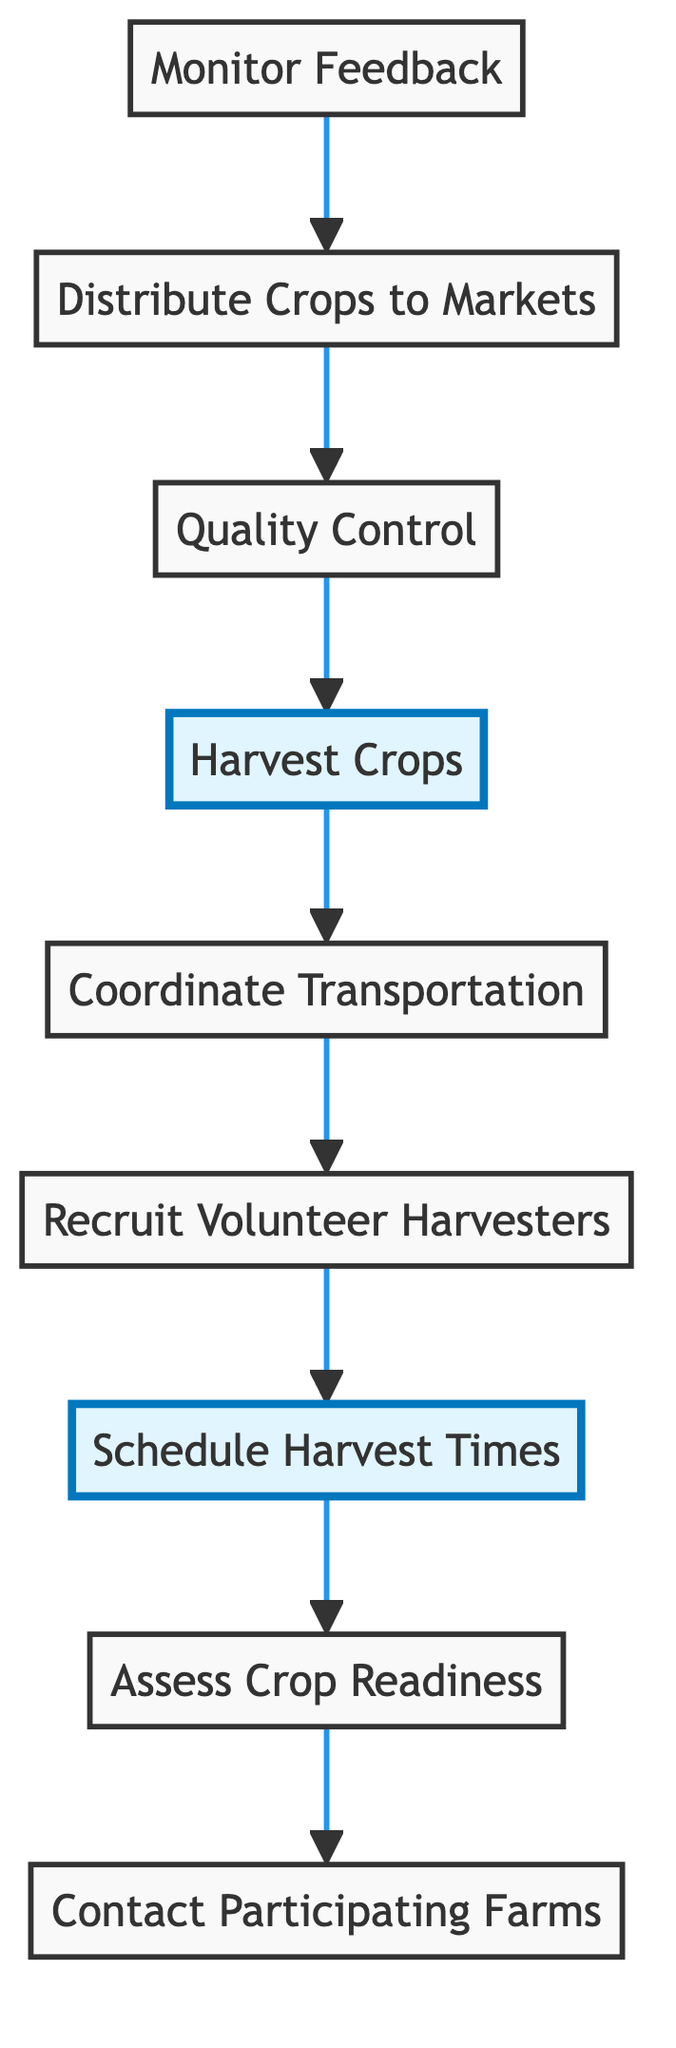What is the first step in the coordination process? The first step, shown at the bottom of the flowchart, is "Contact Participating Farms." This is where outreach begins to enlist the local farms for participation in the harvest coordination program.
Answer: Contact Participating Farms How many distinct steps are in the process? By counting the boxes, there are a total of 9 distinct steps present in the diagram, each representing a stage in the harvesting coordination process.
Answer: 9 What is the last step shown in the process? The last step, at the top of the flowchart, is "Monitor Feedback." This indicates the importance of reviewing feedback after distributing crops to improve future processes.
Answer: Monitor Feedback Which step comes immediately before "Quality Control"? "Distribute Crops to Markets" directly precedes "Quality Control," meaning crops need to be distributed to markets before checking their quality.
Answer: Distribute Crops to Markets In which order are the volunteer harvesters recruited and the harvest times scheduled? "Recruit Volunteer Harvesters" occurs before "Schedule Harvest Times." This means that the recruitment of volunteers is a prerequisite to organizing the schedule for harvest activities.
Answer: Recruit Volunteer Harvesters, Schedule Harvest Times What is the relationship between "Coordinate Transportation" and "Harvest Crops"? "Coordinate Transportation" comes after "Harvest Crops," showing that transportation planning occurs following the completion of the actual harvesting.
Answer: Coordinate Transportation follows Harvest Crops Which step is highlighted in the diagram? The step "Harvest Crops" is highlighted in the flowchart, indicating its critical importance in the overall process of harvest coordination.
Answer: Harvest Crops How does "Assess Crop Readiness" connect to "Contact Participating Farms"? "Assess Crop Readiness" comes after "Contact Participating Farms," indicating that after farms confirm participation, their crop status is evaluated.
Answer: Assess Crop Readiness follows Contact Participating Farms 